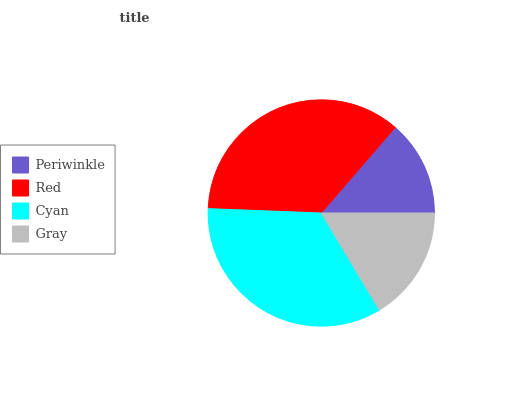Is Periwinkle the minimum?
Answer yes or no. Yes. Is Red the maximum?
Answer yes or no. Yes. Is Cyan the minimum?
Answer yes or no. No. Is Cyan the maximum?
Answer yes or no. No. Is Red greater than Cyan?
Answer yes or no. Yes. Is Cyan less than Red?
Answer yes or no. Yes. Is Cyan greater than Red?
Answer yes or no. No. Is Red less than Cyan?
Answer yes or no. No. Is Cyan the high median?
Answer yes or no. Yes. Is Gray the low median?
Answer yes or no. Yes. Is Periwinkle the high median?
Answer yes or no. No. Is Red the low median?
Answer yes or no. No. 